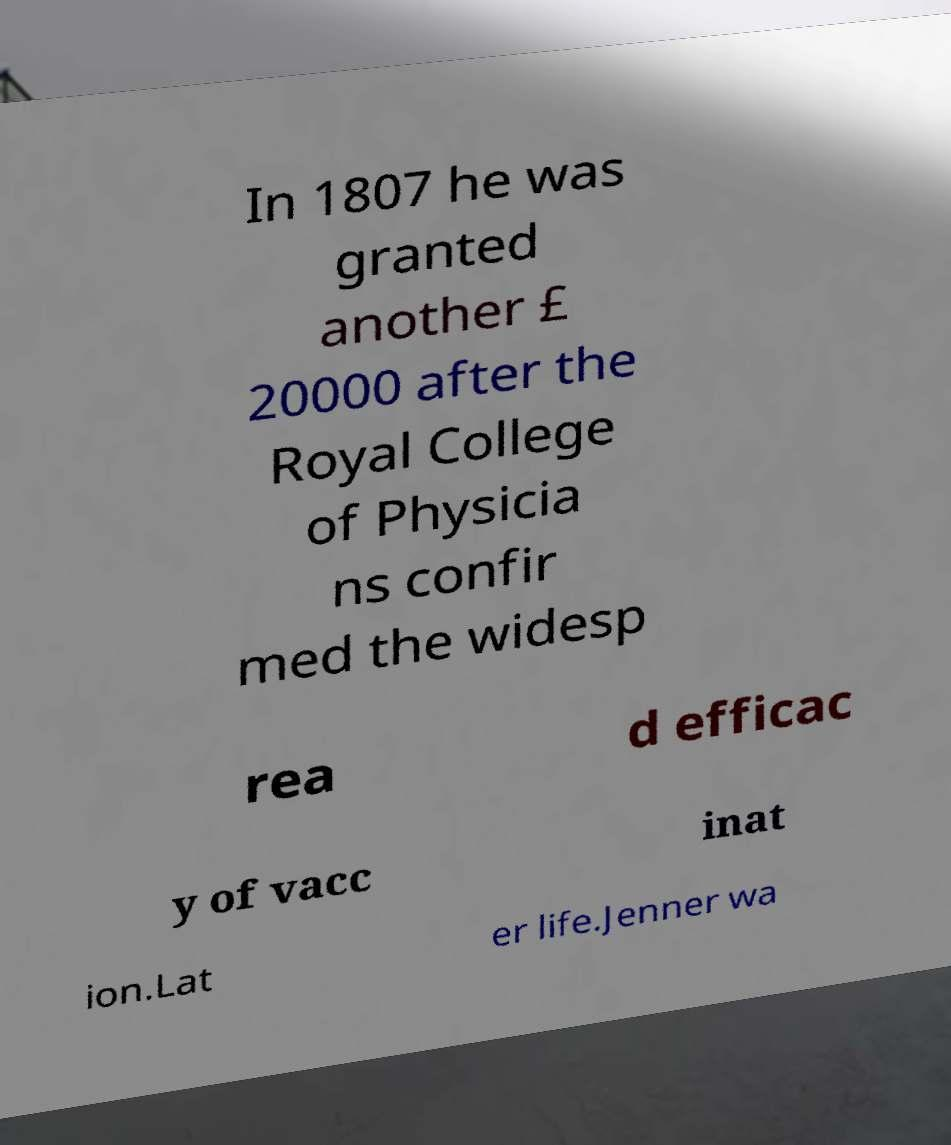For documentation purposes, I need the text within this image transcribed. Could you provide that? In 1807 he was granted another £ 20000 after the Royal College of Physicia ns confir med the widesp rea d efficac y of vacc inat ion.Lat er life.Jenner wa 